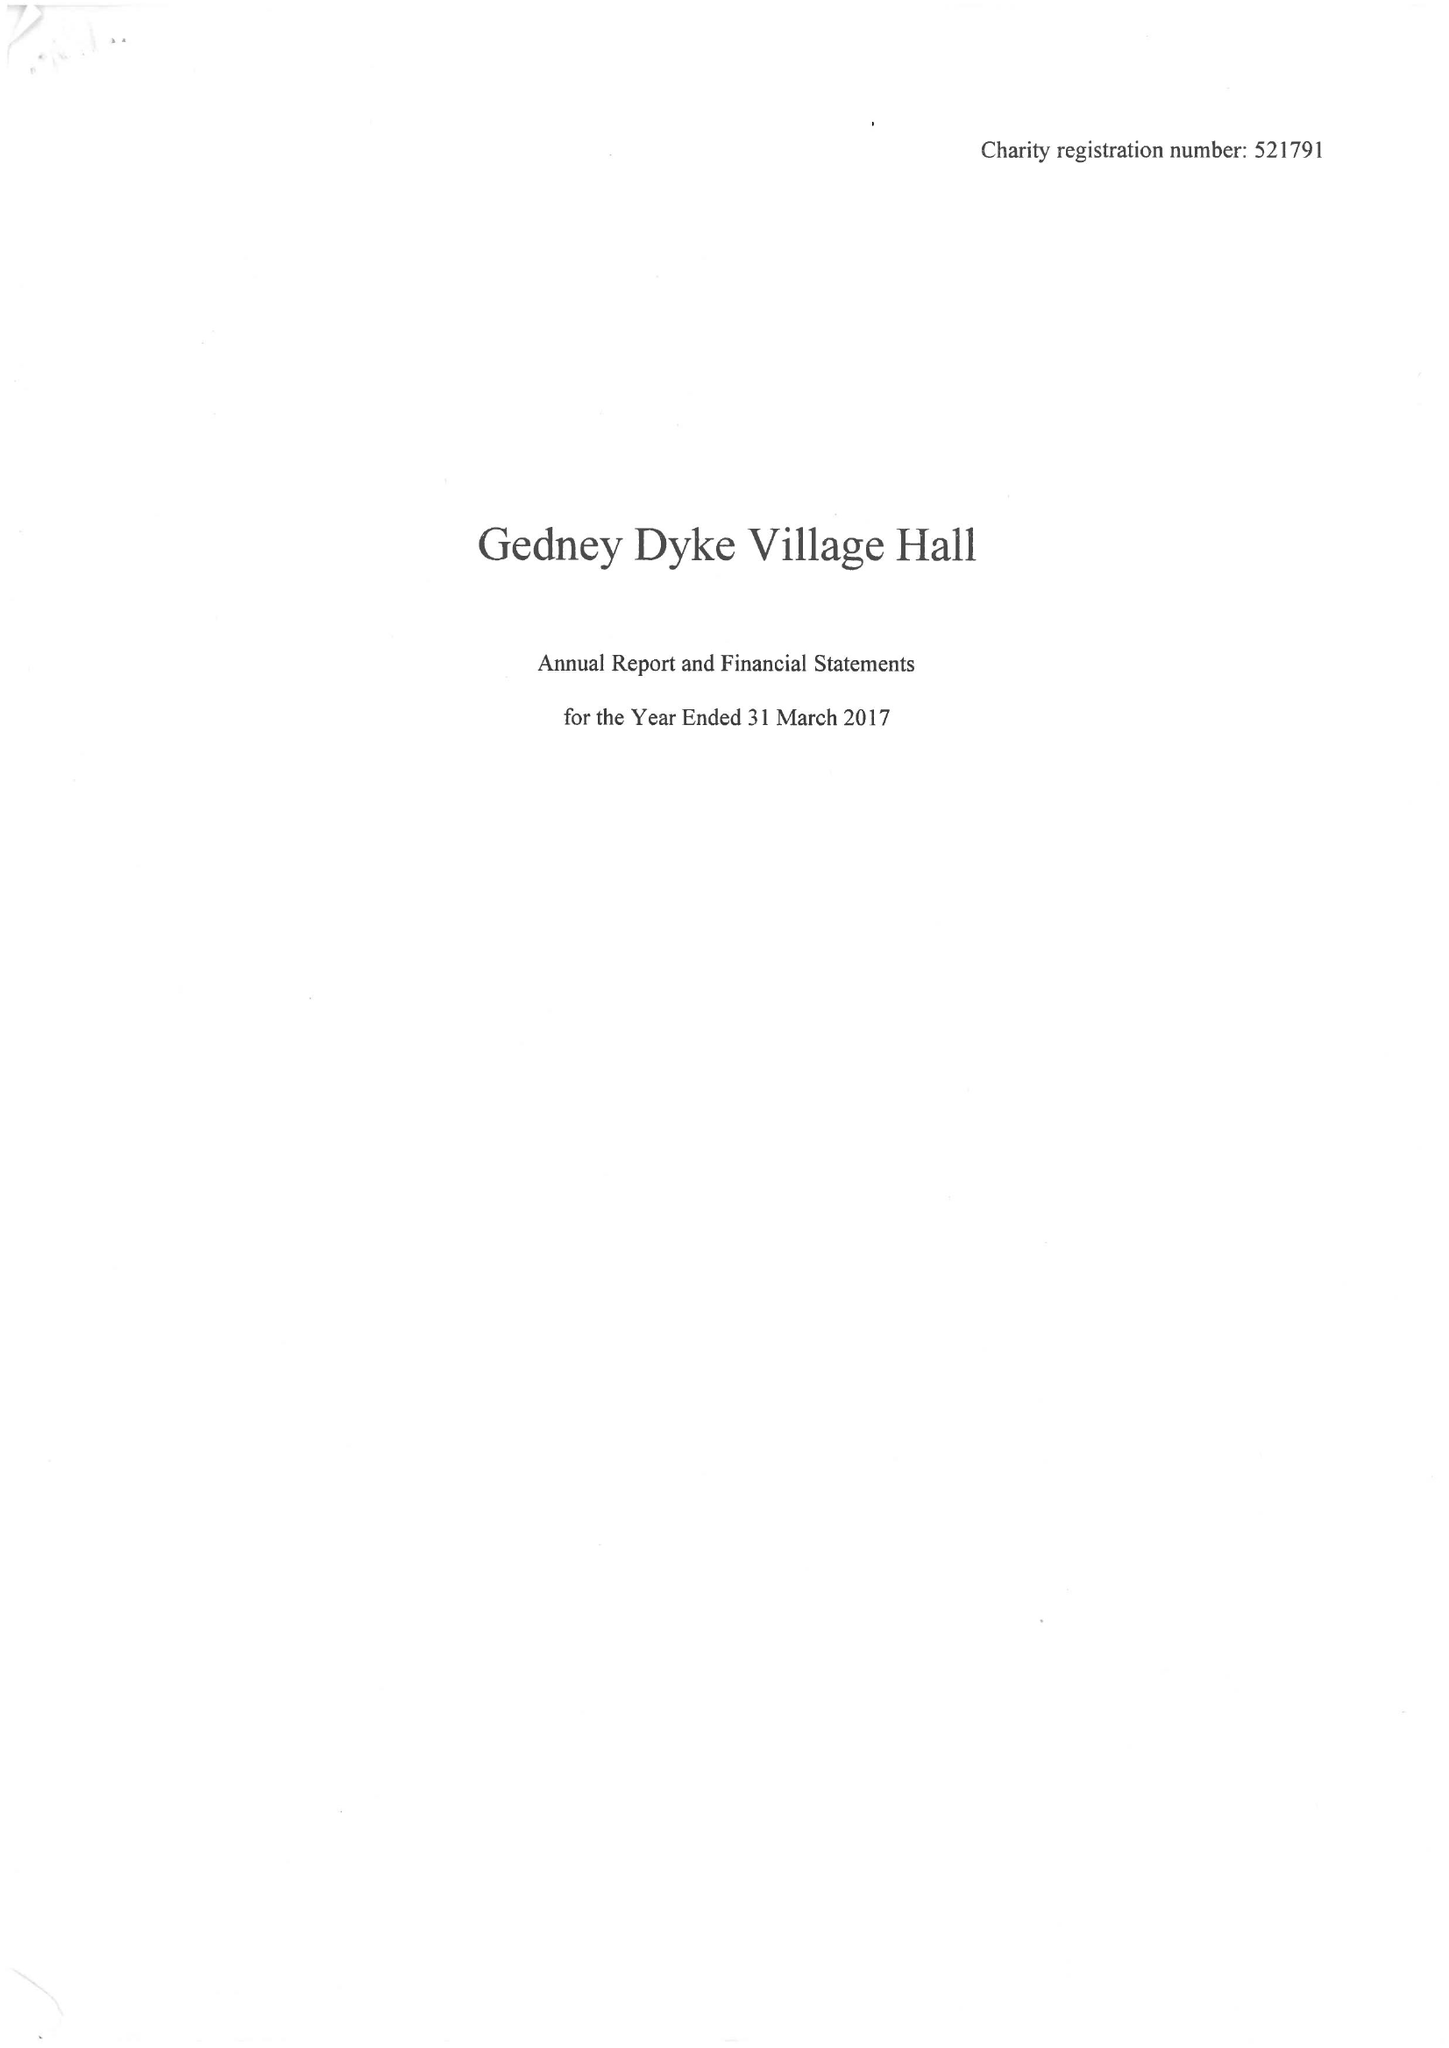What is the value for the address__street_line?
Answer the question using a single word or phrase. 11 MAIN STREET 